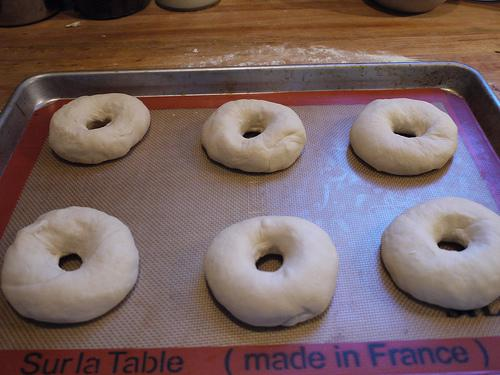Question: where was the baking mat made?
Choices:
A. China.
B. Usa.
C. France.
D. Japan.
Answer with the letter. Answer: C Question: how many bagels are on the baking pan?
Choices:
A. Six.
B. Five.
C. Four.
D. Seven.
Answer with the letter. Answer: A Question: where is the baking pan?
Choices:
A. In the oven.
B. On the table.
C. On the floor.
D. In the cabinet.
Answer with the letter. Answer: B Question: what is in the middle of the bagels?
Choices:
A. Cheese.
B. Salt.
C. Pepper.
D. A hole.
Answer with the letter. Answer: D Question: what colors are the baking mat?
Choices:
A. Brown and blue.
B. Green and red.
C. Yellow and black.
D. Tan and red.
Answer with the letter. Answer: D Question: how many people are in this photo?
Choices:
A. One.
B. Zero.
C. Two.
D. Three.
Answer with the letter. Answer: B Question: why are the bagels on the baking pan?
Choices:
A. They are ready to eat.
B. They are to be baked.
C. They need to be salted.
D. They need to be sold.
Answer with the letter. Answer: B 